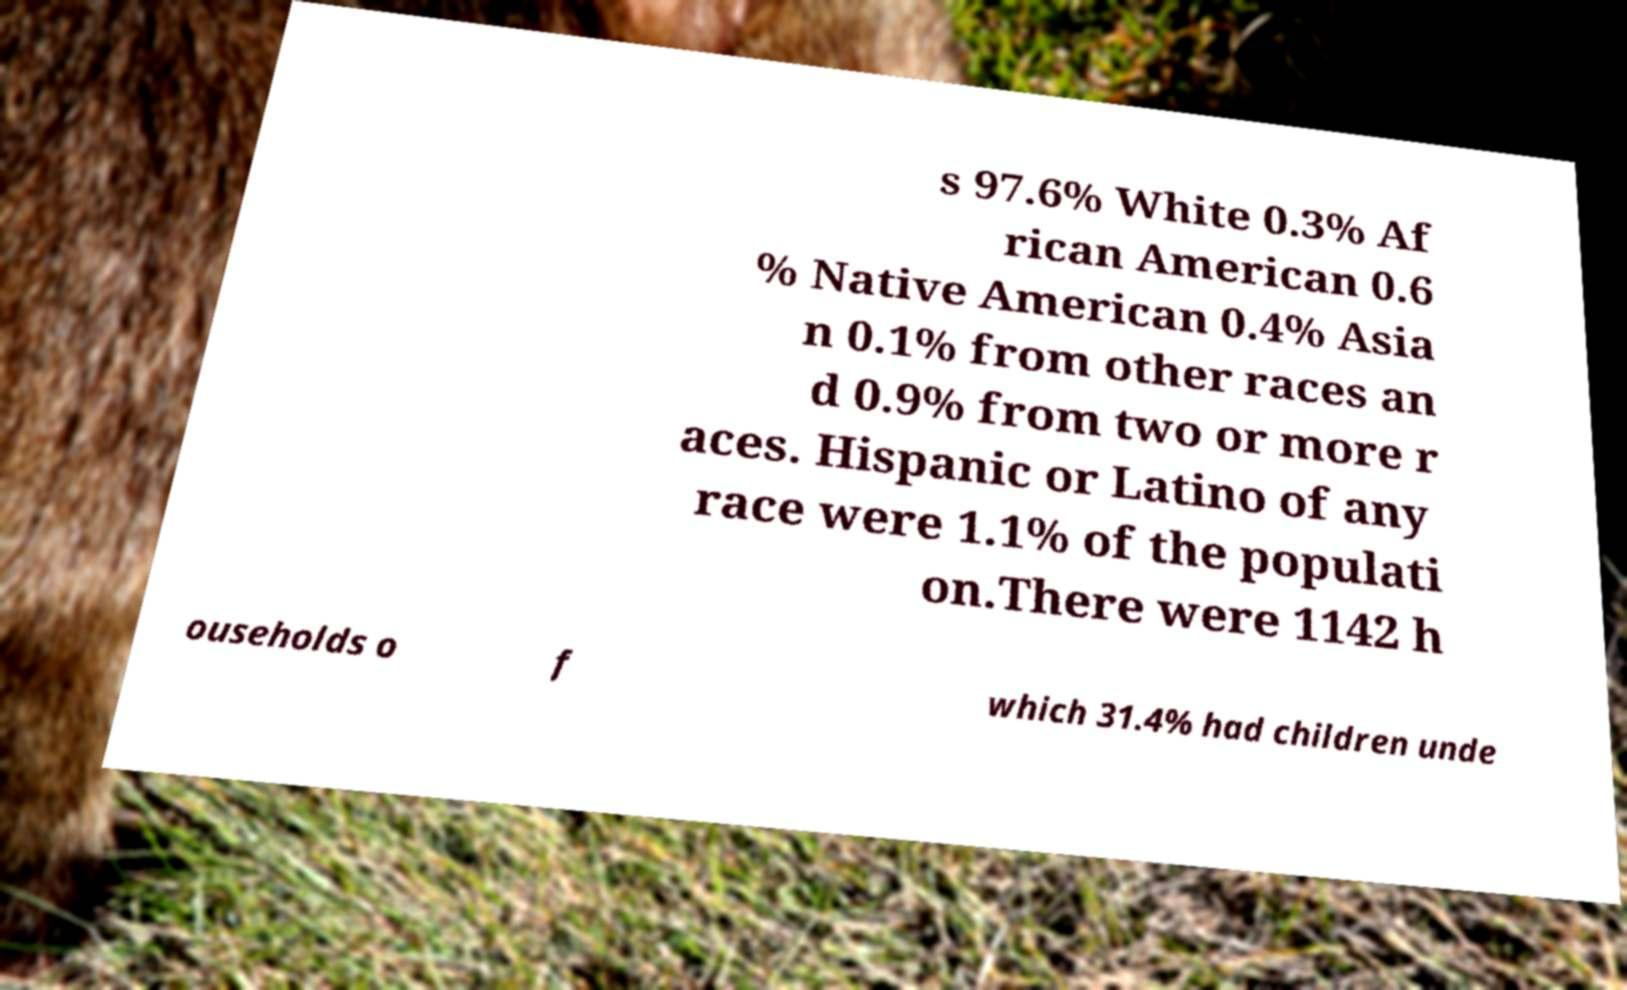Can you accurately transcribe the text from the provided image for me? s 97.6% White 0.3% Af rican American 0.6 % Native American 0.4% Asia n 0.1% from other races an d 0.9% from two or more r aces. Hispanic or Latino of any race were 1.1% of the populati on.There were 1142 h ouseholds o f which 31.4% had children unde 